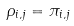Convert formula to latex. <formula><loc_0><loc_0><loc_500><loc_500>\rho _ { i , j } = \pi _ { i , j }</formula> 